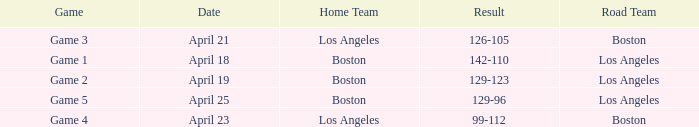WHAT IS THE RESULT OF THE GAME ON APRIL 23? 99-112. 